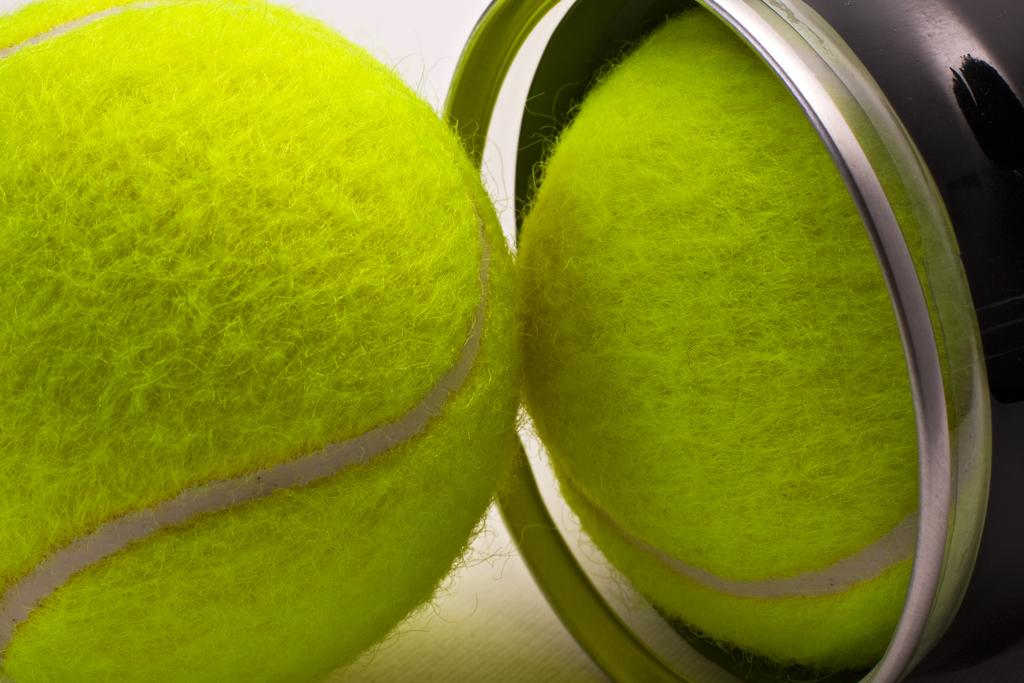How many balls are visible in the image? There are two balls in the image. Where is one of the balls located? One of the balls is inside a box. What type of crib is visible in the image? There is no crib present in the image. How many boys are shown selecting balls in the image? There are no boys present in the image. 